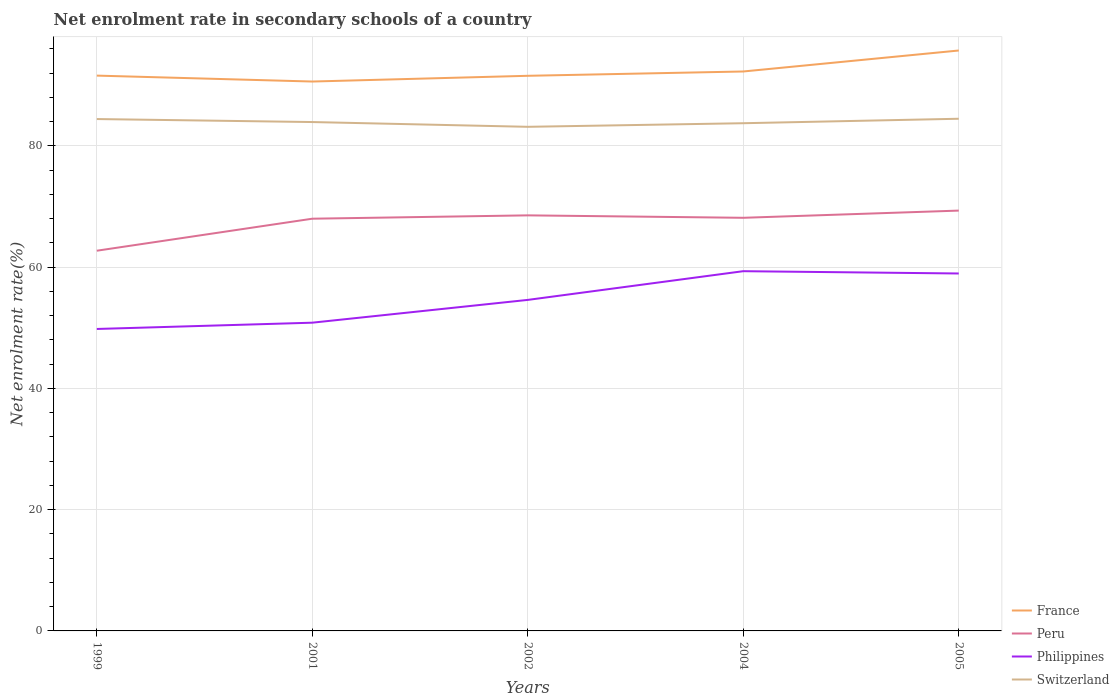Does the line corresponding to Peru intersect with the line corresponding to Philippines?
Your answer should be compact. No. Is the number of lines equal to the number of legend labels?
Offer a very short reply. Yes. Across all years, what is the maximum net enrolment rate in secondary schools in France?
Offer a terse response. 90.63. In which year was the net enrolment rate in secondary schools in Philippines maximum?
Your answer should be compact. 1999. What is the total net enrolment rate in secondary schools in Switzerland in the graph?
Offer a terse response. 0.49. What is the difference between the highest and the second highest net enrolment rate in secondary schools in Peru?
Offer a terse response. 6.62. Is the net enrolment rate in secondary schools in Switzerland strictly greater than the net enrolment rate in secondary schools in Peru over the years?
Make the answer very short. No. How many years are there in the graph?
Offer a terse response. 5. Are the values on the major ticks of Y-axis written in scientific E-notation?
Make the answer very short. No. Does the graph contain any zero values?
Make the answer very short. No. Does the graph contain grids?
Offer a terse response. Yes. Where does the legend appear in the graph?
Keep it short and to the point. Bottom right. How many legend labels are there?
Provide a short and direct response. 4. How are the legend labels stacked?
Offer a terse response. Vertical. What is the title of the graph?
Ensure brevity in your answer.  Net enrolment rate in secondary schools of a country. What is the label or title of the Y-axis?
Provide a short and direct response. Net enrolment rate(%). What is the Net enrolment rate(%) of France in 1999?
Provide a short and direct response. 91.6. What is the Net enrolment rate(%) in Peru in 1999?
Keep it short and to the point. 62.72. What is the Net enrolment rate(%) in Philippines in 1999?
Offer a very short reply. 49.81. What is the Net enrolment rate(%) in Switzerland in 1999?
Offer a terse response. 84.44. What is the Net enrolment rate(%) in France in 2001?
Give a very brief answer. 90.63. What is the Net enrolment rate(%) in Peru in 2001?
Provide a succinct answer. 68. What is the Net enrolment rate(%) in Philippines in 2001?
Offer a terse response. 50.85. What is the Net enrolment rate(%) in Switzerland in 2001?
Keep it short and to the point. 83.95. What is the Net enrolment rate(%) of France in 2002?
Offer a terse response. 91.57. What is the Net enrolment rate(%) of Peru in 2002?
Keep it short and to the point. 68.55. What is the Net enrolment rate(%) in Philippines in 2002?
Provide a short and direct response. 54.61. What is the Net enrolment rate(%) in Switzerland in 2002?
Make the answer very short. 83.16. What is the Net enrolment rate(%) of France in 2004?
Keep it short and to the point. 92.29. What is the Net enrolment rate(%) in Peru in 2004?
Your answer should be compact. 68.15. What is the Net enrolment rate(%) in Philippines in 2004?
Give a very brief answer. 59.34. What is the Net enrolment rate(%) in Switzerland in 2004?
Your response must be concise. 83.75. What is the Net enrolment rate(%) in France in 2005?
Offer a very short reply. 95.75. What is the Net enrolment rate(%) in Peru in 2005?
Provide a succinct answer. 69.34. What is the Net enrolment rate(%) in Philippines in 2005?
Offer a very short reply. 58.96. What is the Net enrolment rate(%) in Switzerland in 2005?
Make the answer very short. 84.49. Across all years, what is the maximum Net enrolment rate(%) of France?
Your answer should be very brief. 95.75. Across all years, what is the maximum Net enrolment rate(%) of Peru?
Your answer should be compact. 69.34. Across all years, what is the maximum Net enrolment rate(%) of Philippines?
Your answer should be compact. 59.34. Across all years, what is the maximum Net enrolment rate(%) of Switzerland?
Make the answer very short. 84.49. Across all years, what is the minimum Net enrolment rate(%) of France?
Keep it short and to the point. 90.63. Across all years, what is the minimum Net enrolment rate(%) of Peru?
Offer a very short reply. 62.72. Across all years, what is the minimum Net enrolment rate(%) of Philippines?
Provide a succinct answer. 49.81. Across all years, what is the minimum Net enrolment rate(%) in Switzerland?
Give a very brief answer. 83.16. What is the total Net enrolment rate(%) in France in the graph?
Ensure brevity in your answer.  461.84. What is the total Net enrolment rate(%) of Peru in the graph?
Provide a short and direct response. 336.76. What is the total Net enrolment rate(%) of Philippines in the graph?
Provide a short and direct response. 273.57. What is the total Net enrolment rate(%) in Switzerland in the graph?
Provide a succinct answer. 419.79. What is the difference between the Net enrolment rate(%) in France in 1999 and that in 2001?
Offer a terse response. 0.98. What is the difference between the Net enrolment rate(%) in Peru in 1999 and that in 2001?
Your answer should be very brief. -5.28. What is the difference between the Net enrolment rate(%) in Philippines in 1999 and that in 2001?
Your answer should be very brief. -1.04. What is the difference between the Net enrolment rate(%) of Switzerland in 1999 and that in 2001?
Ensure brevity in your answer.  0.49. What is the difference between the Net enrolment rate(%) of France in 1999 and that in 2002?
Your response must be concise. 0.03. What is the difference between the Net enrolment rate(%) in Peru in 1999 and that in 2002?
Your response must be concise. -5.83. What is the difference between the Net enrolment rate(%) of Philippines in 1999 and that in 2002?
Ensure brevity in your answer.  -4.8. What is the difference between the Net enrolment rate(%) in Switzerland in 1999 and that in 2002?
Keep it short and to the point. 1.28. What is the difference between the Net enrolment rate(%) of France in 1999 and that in 2004?
Your response must be concise. -0.68. What is the difference between the Net enrolment rate(%) in Peru in 1999 and that in 2004?
Provide a short and direct response. -5.43. What is the difference between the Net enrolment rate(%) of Philippines in 1999 and that in 2004?
Keep it short and to the point. -9.53. What is the difference between the Net enrolment rate(%) of Switzerland in 1999 and that in 2004?
Keep it short and to the point. 0.69. What is the difference between the Net enrolment rate(%) of France in 1999 and that in 2005?
Make the answer very short. -4.14. What is the difference between the Net enrolment rate(%) in Peru in 1999 and that in 2005?
Offer a terse response. -6.62. What is the difference between the Net enrolment rate(%) of Philippines in 1999 and that in 2005?
Give a very brief answer. -9.15. What is the difference between the Net enrolment rate(%) of Switzerland in 1999 and that in 2005?
Keep it short and to the point. -0.05. What is the difference between the Net enrolment rate(%) in France in 2001 and that in 2002?
Provide a short and direct response. -0.95. What is the difference between the Net enrolment rate(%) of Peru in 2001 and that in 2002?
Keep it short and to the point. -0.55. What is the difference between the Net enrolment rate(%) of Philippines in 2001 and that in 2002?
Your answer should be compact. -3.76. What is the difference between the Net enrolment rate(%) in Switzerland in 2001 and that in 2002?
Provide a short and direct response. 0.79. What is the difference between the Net enrolment rate(%) in France in 2001 and that in 2004?
Provide a short and direct response. -1.66. What is the difference between the Net enrolment rate(%) in Peru in 2001 and that in 2004?
Provide a succinct answer. -0.15. What is the difference between the Net enrolment rate(%) of Philippines in 2001 and that in 2004?
Make the answer very short. -8.5. What is the difference between the Net enrolment rate(%) of Switzerland in 2001 and that in 2004?
Give a very brief answer. 0.19. What is the difference between the Net enrolment rate(%) in France in 2001 and that in 2005?
Provide a succinct answer. -5.12. What is the difference between the Net enrolment rate(%) in Peru in 2001 and that in 2005?
Your response must be concise. -1.34. What is the difference between the Net enrolment rate(%) of Philippines in 2001 and that in 2005?
Offer a very short reply. -8.12. What is the difference between the Net enrolment rate(%) in Switzerland in 2001 and that in 2005?
Your response must be concise. -0.54. What is the difference between the Net enrolment rate(%) of France in 2002 and that in 2004?
Keep it short and to the point. -0.71. What is the difference between the Net enrolment rate(%) in Peru in 2002 and that in 2004?
Your answer should be compact. 0.4. What is the difference between the Net enrolment rate(%) in Philippines in 2002 and that in 2004?
Offer a very short reply. -4.74. What is the difference between the Net enrolment rate(%) in Switzerland in 2002 and that in 2004?
Give a very brief answer. -0.59. What is the difference between the Net enrolment rate(%) in France in 2002 and that in 2005?
Make the answer very short. -4.17. What is the difference between the Net enrolment rate(%) of Peru in 2002 and that in 2005?
Ensure brevity in your answer.  -0.78. What is the difference between the Net enrolment rate(%) in Philippines in 2002 and that in 2005?
Your response must be concise. -4.36. What is the difference between the Net enrolment rate(%) in Switzerland in 2002 and that in 2005?
Your answer should be very brief. -1.33. What is the difference between the Net enrolment rate(%) in France in 2004 and that in 2005?
Provide a succinct answer. -3.46. What is the difference between the Net enrolment rate(%) of Peru in 2004 and that in 2005?
Offer a very short reply. -1.19. What is the difference between the Net enrolment rate(%) of Philippines in 2004 and that in 2005?
Your answer should be very brief. 0.38. What is the difference between the Net enrolment rate(%) of Switzerland in 2004 and that in 2005?
Ensure brevity in your answer.  -0.74. What is the difference between the Net enrolment rate(%) in France in 1999 and the Net enrolment rate(%) in Peru in 2001?
Make the answer very short. 23.6. What is the difference between the Net enrolment rate(%) of France in 1999 and the Net enrolment rate(%) of Philippines in 2001?
Offer a very short reply. 40.76. What is the difference between the Net enrolment rate(%) in France in 1999 and the Net enrolment rate(%) in Switzerland in 2001?
Your answer should be very brief. 7.66. What is the difference between the Net enrolment rate(%) of Peru in 1999 and the Net enrolment rate(%) of Philippines in 2001?
Provide a succinct answer. 11.87. What is the difference between the Net enrolment rate(%) in Peru in 1999 and the Net enrolment rate(%) in Switzerland in 2001?
Your answer should be compact. -21.23. What is the difference between the Net enrolment rate(%) in Philippines in 1999 and the Net enrolment rate(%) in Switzerland in 2001?
Make the answer very short. -34.14. What is the difference between the Net enrolment rate(%) in France in 1999 and the Net enrolment rate(%) in Peru in 2002?
Offer a terse response. 23.05. What is the difference between the Net enrolment rate(%) in France in 1999 and the Net enrolment rate(%) in Philippines in 2002?
Keep it short and to the point. 37. What is the difference between the Net enrolment rate(%) of France in 1999 and the Net enrolment rate(%) of Switzerland in 2002?
Offer a terse response. 8.45. What is the difference between the Net enrolment rate(%) of Peru in 1999 and the Net enrolment rate(%) of Philippines in 2002?
Offer a terse response. 8.11. What is the difference between the Net enrolment rate(%) of Peru in 1999 and the Net enrolment rate(%) of Switzerland in 2002?
Offer a very short reply. -20.44. What is the difference between the Net enrolment rate(%) in Philippines in 1999 and the Net enrolment rate(%) in Switzerland in 2002?
Provide a succinct answer. -33.35. What is the difference between the Net enrolment rate(%) of France in 1999 and the Net enrolment rate(%) of Peru in 2004?
Ensure brevity in your answer.  23.45. What is the difference between the Net enrolment rate(%) of France in 1999 and the Net enrolment rate(%) of Philippines in 2004?
Your answer should be compact. 32.26. What is the difference between the Net enrolment rate(%) in France in 1999 and the Net enrolment rate(%) in Switzerland in 2004?
Your response must be concise. 7.85. What is the difference between the Net enrolment rate(%) of Peru in 1999 and the Net enrolment rate(%) of Philippines in 2004?
Your answer should be very brief. 3.38. What is the difference between the Net enrolment rate(%) in Peru in 1999 and the Net enrolment rate(%) in Switzerland in 2004?
Give a very brief answer. -21.03. What is the difference between the Net enrolment rate(%) of Philippines in 1999 and the Net enrolment rate(%) of Switzerland in 2004?
Offer a terse response. -33.94. What is the difference between the Net enrolment rate(%) in France in 1999 and the Net enrolment rate(%) in Peru in 2005?
Offer a terse response. 22.27. What is the difference between the Net enrolment rate(%) in France in 1999 and the Net enrolment rate(%) in Philippines in 2005?
Provide a succinct answer. 32.64. What is the difference between the Net enrolment rate(%) in France in 1999 and the Net enrolment rate(%) in Switzerland in 2005?
Provide a succinct answer. 7.12. What is the difference between the Net enrolment rate(%) in Peru in 1999 and the Net enrolment rate(%) in Philippines in 2005?
Your answer should be compact. 3.75. What is the difference between the Net enrolment rate(%) in Peru in 1999 and the Net enrolment rate(%) in Switzerland in 2005?
Offer a very short reply. -21.77. What is the difference between the Net enrolment rate(%) of Philippines in 1999 and the Net enrolment rate(%) of Switzerland in 2005?
Ensure brevity in your answer.  -34.68. What is the difference between the Net enrolment rate(%) of France in 2001 and the Net enrolment rate(%) of Peru in 2002?
Your answer should be very brief. 22.08. What is the difference between the Net enrolment rate(%) in France in 2001 and the Net enrolment rate(%) in Philippines in 2002?
Offer a very short reply. 36.02. What is the difference between the Net enrolment rate(%) of France in 2001 and the Net enrolment rate(%) of Switzerland in 2002?
Provide a succinct answer. 7.47. What is the difference between the Net enrolment rate(%) in Peru in 2001 and the Net enrolment rate(%) in Philippines in 2002?
Offer a terse response. 13.39. What is the difference between the Net enrolment rate(%) of Peru in 2001 and the Net enrolment rate(%) of Switzerland in 2002?
Your answer should be compact. -15.16. What is the difference between the Net enrolment rate(%) of Philippines in 2001 and the Net enrolment rate(%) of Switzerland in 2002?
Provide a succinct answer. -32.31. What is the difference between the Net enrolment rate(%) of France in 2001 and the Net enrolment rate(%) of Peru in 2004?
Offer a very short reply. 22.48. What is the difference between the Net enrolment rate(%) in France in 2001 and the Net enrolment rate(%) in Philippines in 2004?
Offer a very short reply. 31.29. What is the difference between the Net enrolment rate(%) of France in 2001 and the Net enrolment rate(%) of Switzerland in 2004?
Your answer should be very brief. 6.88. What is the difference between the Net enrolment rate(%) in Peru in 2001 and the Net enrolment rate(%) in Philippines in 2004?
Provide a short and direct response. 8.66. What is the difference between the Net enrolment rate(%) of Peru in 2001 and the Net enrolment rate(%) of Switzerland in 2004?
Your answer should be compact. -15.75. What is the difference between the Net enrolment rate(%) of Philippines in 2001 and the Net enrolment rate(%) of Switzerland in 2004?
Keep it short and to the point. -32.9. What is the difference between the Net enrolment rate(%) in France in 2001 and the Net enrolment rate(%) in Peru in 2005?
Your answer should be compact. 21.29. What is the difference between the Net enrolment rate(%) in France in 2001 and the Net enrolment rate(%) in Philippines in 2005?
Your response must be concise. 31.66. What is the difference between the Net enrolment rate(%) in France in 2001 and the Net enrolment rate(%) in Switzerland in 2005?
Keep it short and to the point. 6.14. What is the difference between the Net enrolment rate(%) in Peru in 2001 and the Net enrolment rate(%) in Philippines in 2005?
Make the answer very short. 9.04. What is the difference between the Net enrolment rate(%) in Peru in 2001 and the Net enrolment rate(%) in Switzerland in 2005?
Give a very brief answer. -16.49. What is the difference between the Net enrolment rate(%) in Philippines in 2001 and the Net enrolment rate(%) in Switzerland in 2005?
Your response must be concise. -33.64. What is the difference between the Net enrolment rate(%) of France in 2002 and the Net enrolment rate(%) of Peru in 2004?
Your response must be concise. 23.43. What is the difference between the Net enrolment rate(%) of France in 2002 and the Net enrolment rate(%) of Philippines in 2004?
Your answer should be compact. 32.23. What is the difference between the Net enrolment rate(%) in France in 2002 and the Net enrolment rate(%) in Switzerland in 2004?
Your answer should be very brief. 7.82. What is the difference between the Net enrolment rate(%) of Peru in 2002 and the Net enrolment rate(%) of Philippines in 2004?
Make the answer very short. 9.21. What is the difference between the Net enrolment rate(%) of Peru in 2002 and the Net enrolment rate(%) of Switzerland in 2004?
Provide a short and direct response. -15.2. What is the difference between the Net enrolment rate(%) of Philippines in 2002 and the Net enrolment rate(%) of Switzerland in 2004?
Keep it short and to the point. -29.15. What is the difference between the Net enrolment rate(%) in France in 2002 and the Net enrolment rate(%) in Peru in 2005?
Give a very brief answer. 22.24. What is the difference between the Net enrolment rate(%) in France in 2002 and the Net enrolment rate(%) in Philippines in 2005?
Provide a succinct answer. 32.61. What is the difference between the Net enrolment rate(%) of France in 2002 and the Net enrolment rate(%) of Switzerland in 2005?
Your answer should be very brief. 7.09. What is the difference between the Net enrolment rate(%) in Peru in 2002 and the Net enrolment rate(%) in Philippines in 2005?
Provide a succinct answer. 9.59. What is the difference between the Net enrolment rate(%) of Peru in 2002 and the Net enrolment rate(%) of Switzerland in 2005?
Your response must be concise. -15.94. What is the difference between the Net enrolment rate(%) of Philippines in 2002 and the Net enrolment rate(%) of Switzerland in 2005?
Give a very brief answer. -29.88. What is the difference between the Net enrolment rate(%) of France in 2004 and the Net enrolment rate(%) of Peru in 2005?
Ensure brevity in your answer.  22.95. What is the difference between the Net enrolment rate(%) in France in 2004 and the Net enrolment rate(%) in Philippines in 2005?
Your answer should be very brief. 33.32. What is the difference between the Net enrolment rate(%) of France in 2004 and the Net enrolment rate(%) of Switzerland in 2005?
Make the answer very short. 7.8. What is the difference between the Net enrolment rate(%) in Peru in 2004 and the Net enrolment rate(%) in Philippines in 2005?
Keep it short and to the point. 9.19. What is the difference between the Net enrolment rate(%) of Peru in 2004 and the Net enrolment rate(%) of Switzerland in 2005?
Give a very brief answer. -16.34. What is the difference between the Net enrolment rate(%) of Philippines in 2004 and the Net enrolment rate(%) of Switzerland in 2005?
Your response must be concise. -25.15. What is the average Net enrolment rate(%) of France per year?
Give a very brief answer. 92.37. What is the average Net enrolment rate(%) in Peru per year?
Give a very brief answer. 67.35. What is the average Net enrolment rate(%) in Philippines per year?
Your answer should be compact. 54.71. What is the average Net enrolment rate(%) in Switzerland per year?
Provide a short and direct response. 83.96. In the year 1999, what is the difference between the Net enrolment rate(%) in France and Net enrolment rate(%) in Peru?
Keep it short and to the point. 28.89. In the year 1999, what is the difference between the Net enrolment rate(%) of France and Net enrolment rate(%) of Philippines?
Give a very brief answer. 41.79. In the year 1999, what is the difference between the Net enrolment rate(%) in France and Net enrolment rate(%) in Switzerland?
Offer a very short reply. 7.17. In the year 1999, what is the difference between the Net enrolment rate(%) of Peru and Net enrolment rate(%) of Philippines?
Provide a short and direct response. 12.91. In the year 1999, what is the difference between the Net enrolment rate(%) in Peru and Net enrolment rate(%) in Switzerland?
Offer a terse response. -21.72. In the year 1999, what is the difference between the Net enrolment rate(%) of Philippines and Net enrolment rate(%) of Switzerland?
Your answer should be very brief. -34.63. In the year 2001, what is the difference between the Net enrolment rate(%) in France and Net enrolment rate(%) in Peru?
Give a very brief answer. 22.63. In the year 2001, what is the difference between the Net enrolment rate(%) in France and Net enrolment rate(%) in Philippines?
Make the answer very short. 39.78. In the year 2001, what is the difference between the Net enrolment rate(%) in France and Net enrolment rate(%) in Switzerland?
Your response must be concise. 6.68. In the year 2001, what is the difference between the Net enrolment rate(%) in Peru and Net enrolment rate(%) in Philippines?
Ensure brevity in your answer.  17.15. In the year 2001, what is the difference between the Net enrolment rate(%) in Peru and Net enrolment rate(%) in Switzerland?
Provide a short and direct response. -15.95. In the year 2001, what is the difference between the Net enrolment rate(%) of Philippines and Net enrolment rate(%) of Switzerland?
Your answer should be very brief. -33.1. In the year 2002, what is the difference between the Net enrolment rate(%) in France and Net enrolment rate(%) in Peru?
Offer a very short reply. 23.02. In the year 2002, what is the difference between the Net enrolment rate(%) of France and Net enrolment rate(%) of Philippines?
Give a very brief answer. 36.97. In the year 2002, what is the difference between the Net enrolment rate(%) of France and Net enrolment rate(%) of Switzerland?
Offer a terse response. 8.42. In the year 2002, what is the difference between the Net enrolment rate(%) of Peru and Net enrolment rate(%) of Philippines?
Offer a terse response. 13.95. In the year 2002, what is the difference between the Net enrolment rate(%) of Peru and Net enrolment rate(%) of Switzerland?
Your response must be concise. -14.61. In the year 2002, what is the difference between the Net enrolment rate(%) of Philippines and Net enrolment rate(%) of Switzerland?
Give a very brief answer. -28.55. In the year 2004, what is the difference between the Net enrolment rate(%) in France and Net enrolment rate(%) in Peru?
Your response must be concise. 24.14. In the year 2004, what is the difference between the Net enrolment rate(%) of France and Net enrolment rate(%) of Philippines?
Offer a terse response. 32.94. In the year 2004, what is the difference between the Net enrolment rate(%) in France and Net enrolment rate(%) in Switzerland?
Make the answer very short. 8.53. In the year 2004, what is the difference between the Net enrolment rate(%) in Peru and Net enrolment rate(%) in Philippines?
Your answer should be very brief. 8.81. In the year 2004, what is the difference between the Net enrolment rate(%) in Peru and Net enrolment rate(%) in Switzerland?
Your answer should be very brief. -15.6. In the year 2004, what is the difference between the Net enrolment rate(%) of Philippines and Net enrolment rate(%) of Switzerland?
Give a very brief answer. -24.41. In the year 2005, what is the difference between the Net enrolment rate(%) of France and Net enrolment rate(%) of Peru?
Keep it short and to the point. 26.41. In the year 2005, what is the difference between the Net enrolment rate(%) of France and Net enrolment rate(%) of Philippines?
Your answer should be very brief. 36.78. In the year 2005, what is the difference between the Net enrolment rate(%) of France and Net enrolment rate(%) of Switzerland?
Ensure brevity in your answer.  11.26. In the year 2005, what is the difference between the Net enrolment rate(%) in Peru and Net enrolment rate(%) in Philippines?
Provide a succinct answer. 10.37. In the year 2005, what is the difference between the Net enrolment rate(%) of Peru and Net enrolment rate(%) of Switzerland?
Ensure brevity in your answer.  -15.15. In the year 2005, what is the difference between the Net enrolment rate(%) in Philippines and Net enrolment rate(%) in Switzerland?
Your response must be concise. -25.52. What is the ratio of the Net enrolment rate(%) in France in 1999 to that in 2001?
Offer a terse response. 1.01. What is the ratio of the Net enrolment rate(%) in Peru in 1999 to that in 2001?
Your answer should be very brief. 0.92. What is the ratio of the Net enrolment rate(%) of Philippines in 1999 to that in 2001?
Your response must be concise. 0.98. What is the ratio of the Net enrolment rate(%) in Switzerland in 1999 to that in 2001?
Ensure brevity in your answer.  1.01. What is the ratio of the Net enrolment rate(%) of France in 1999 to that in 2002?
Provide a succinct answer. 1. What is the ratio of the Net enrolment rate(%) of Peru in 1999 to that in 2002?
Your answer should be compact. 0.91. What is the ratio of the Net enrolment rate(%) in Philippines in 1999 to that in 2002?
Give a very brief answer. 0.91. What is the ratio of the Net enrolment rate(%) of Switzerland in 1999 to that in 2002?
Provide a short and direct response. 1.02. What is the ratio of the Net enrolment rate(%) in Peru in 1999 to that in 2004?
Your answer should be compact. 0.92. What is the ratio of the Net enrolment rate(%) of Philippines in 1999 to that in 2004?
Your response must be concise. 0.84. What is the ratio of the Net enrolment rate(%) in Switzerland in 1999 to that in 2004?
Provide a short and direct response. 1.01. What is the ratio of the Net enrolment rate(%) in France in 1999 to that in 2005?
Give a very brief answer. 0.96. What is the ratio of the Net enrolment rate(%) in Peru in 1999 to that in 2005?
Make the answer very short. 0.9. What is the ratio of the Net enrolment rate(%) in Philippines in 1999 to that in 2005?
Offer a terse response. 0.84. What is the ratio of the Net enrolment rate(%) of Peru in 2001 to that in 2002?
Provide a short and direct response. 0.99. What is the ratio of the Net enrolment rate(%) of Philippines in 2001 to that in 2002?
Your answer should be very brief. 0.93. What is the ratio of the Net enrolment rate(%) in Switzerland in 2001 to that in 2002?
Your answer should be very brief. 1.01. What is the ratio of the Net enrolment rate(%) of France in 2001 to that in 2004?
Ensure brevity in your answer.  0.98. What is the ratio of the Net enrolment rate(%) in Peru in 2001 to that in 2004?
Ensure brevity in your answer.  1. What is the ratio of the Net enrolment rate(%) in Philippines in 2001 to that in 2004?
Give a very brief answer. 0.86. What is the ratio of the Net enrolment rate(%) in France in 2001 to that in 2005?
Offer a terse response. 0.95. What is the ratio of the Net enrolment rate(%) of Peru in 2001 to that in 2005?
Provide a succinct answer. 0.98. What is the ratio of the Net enrolment rate(%) in Philippines in 2001 to that in 2005?
Your answer should be very brief. 0.86. What is the ratio of the Net enrolment rate(%) of Switzerland in 2001 to that in 2005?
Your answer should be very brief. 0.99. What is the ratio of the Net enrolment rate(%) of France in 2002 to that in 2004?
Your answer should be compact. 0.99. What is the ratio of the Net enrolment rate(%) of Peru in 2002 to that in 2004?
Ensure brevity in your answer.  1.01. What is the ratio of the Net enrolment rate(%) of Philippines in 2002 to that in 2004?
Keep it short and to the point. 0.92. What is the ratio of the Net enrolment rate(%) of Switzerland in 2002 to that in 2004?
Your answer should be very brief. 0.99. What is the ratio of the Net enrolment rate(%) in France in 2002 to that in 2005?
Keep it short and to the point. 0.96. What is the ratio of the Net enrolment rate(%) of Peru in 2002 to that in 2005?
Offer a terse response. 0.99. What is the ratio of the Net enrolment rate(%) in Philippines in 2002 to that in 2005?
Your response must be concise. 0.93. What is the ratio of the Net enrolment rate(%) of Switzerland in 2002 to that in 2005?
Make the answer very short. 0.98. What is the ratio of the Net enrolment rate(%) in France in 2004 to that in 2005?
Offer a terse response. 0.96. What is the ratio of the Net enrolment rate(%) of Peru in 2004 to that in 2005?
Offer a terse response. 0.98. What is the ratio of the Net enrolment rate(%) in Philippines in 2004 to that in 2005?
Provide a succinct answer. 1.01. What is the ratio of the Net enrolment rate(%) of Switzerland in 2004 to that in 2005?
Ensure brevity in your answer.  0.99. What is the difference between the highest and the second highest Net enrolment rate(%) of France?
Offer a very short reply. 3.46. What is the difference between the highest and the second highest Net enrolment rate(%) in Peru?
Your response must be concise. 0.78. What is the difference between the highest and the second highest Net enrolment rate(%) of Philippines?
Offer a very short reply. 0.38. What is the difference between the highest and the second highest Net enrolment rate(%) of Switzerland?
Give a very brief answer. 0.05. What is the difference between the highest and the lowest Net enrolment rate(%) in France?
Offer a very short reply. 5.12. What is the difference between the highest and the lowest Net enrolment rate(%) of Peru?
Give a very brief answer. 6.62. What is the difference between the highest and the lowest Net enrolment rate(%) of Philippines?
Provide a short and direct response. 9.53. What is the difference between the highest and the lowest Net enrolment rate(%) of Switzerland?
Your answer should be very brief. 1.33. 